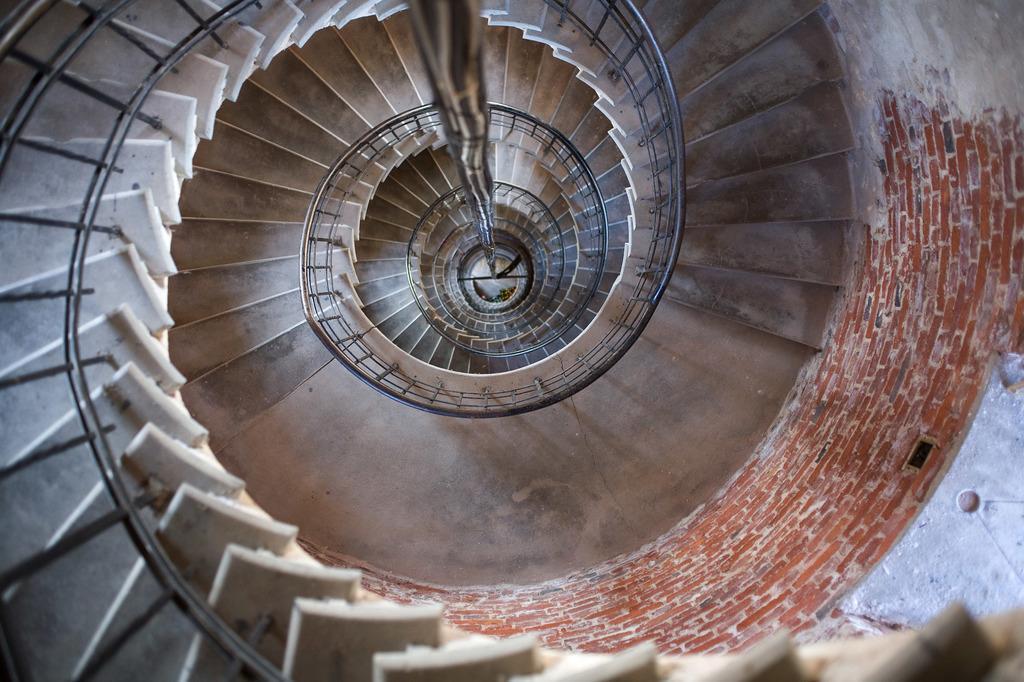Can you describe this image briefly? In this picture there is a staircase and there is a hand rail and there is a pole. On the right side of the image there is a wall. 